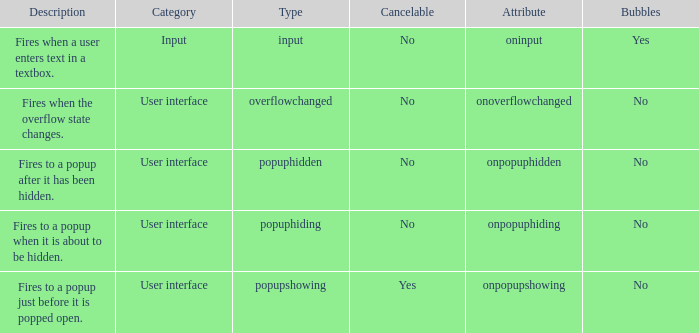 how many bubbles with category being input 1.0. 